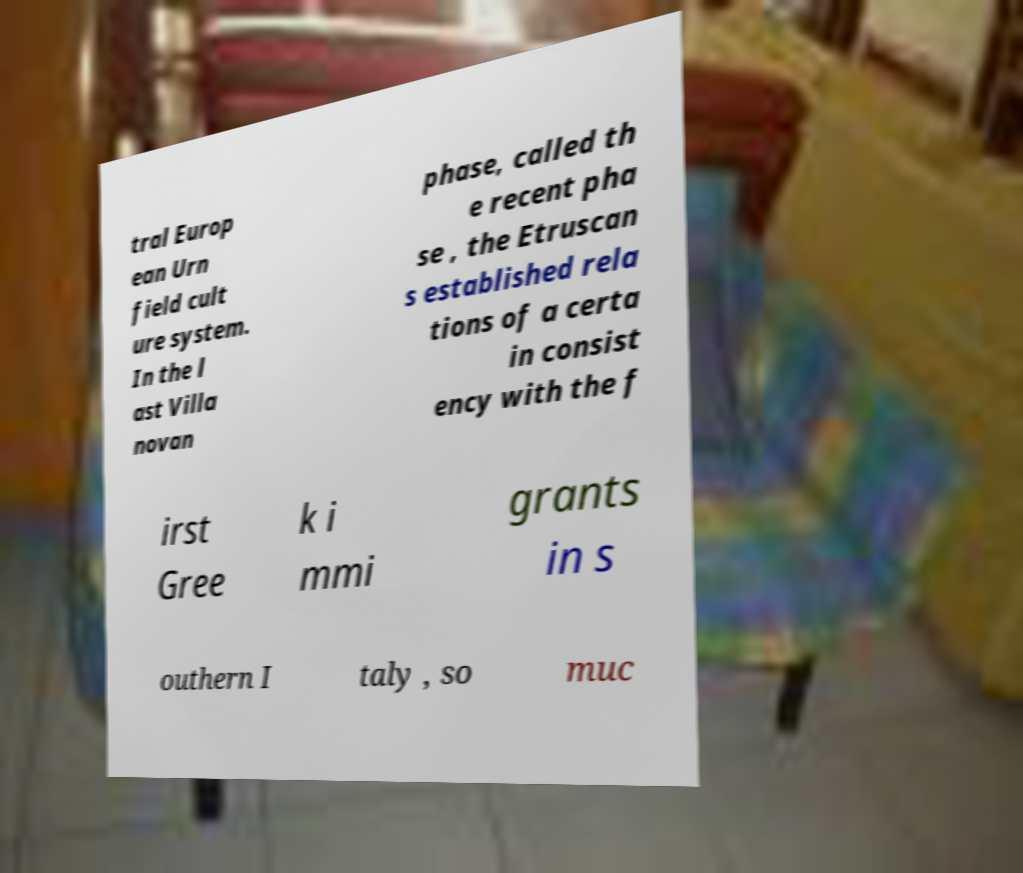Please read and relay the text visible in this image. What does it say? tral Europ ean Urn field cult ure system. In the l ast Villa novan phase, called th e recent pha se , the Etruscan s established rela tions of a certa in consist ency with the f irst Gree k i mmi grants in s outhern I taly , so muc 